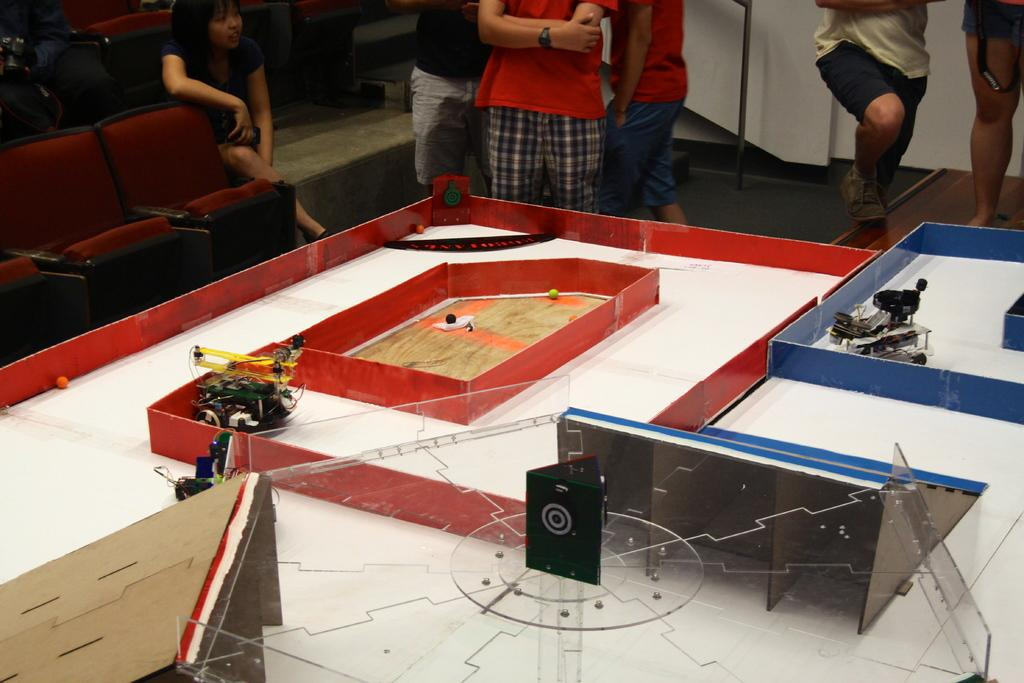What is the main object in the image? There is a table in the image. What is on the table? There are many items on the table, including cars. Are there any people in the image? Yes, there are people standing near the table. What type of lock is used to secure the cheese on the table? There is no cheese present in the image, and therefore no lock is needed to secure it. 